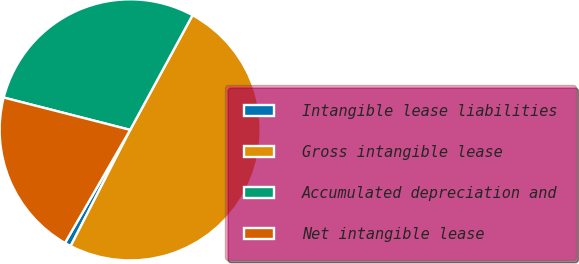Convert chart to OTSL. <chart><loc_0><loc_0><loc_500><loc_500><pie_chart><fcel>Intangible lease liabilities<fcel>Gross intangible lease<fcel>Accumulated depreciation and<fcel>Net intangible lease<nl><fcel>0.79%<fcel>49.6%<fcel>28.94%<fcel>20.66%<nl></chart> 